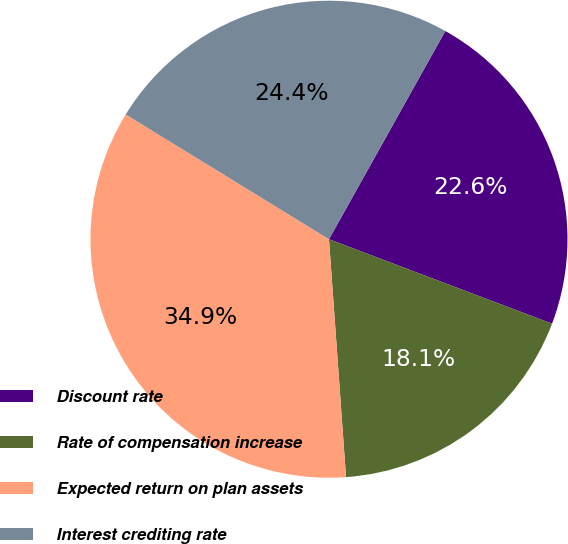Convert chart to OTSL. <chart><loc_0><loc_0><loc_500><loc_500><pie_chart><fcel>Discount rate<fcel>Rate of compensation increase<fcel>Expected return on plan assets<fcel>Interest crediting rate<nl><fcel>22.65%<fcel>18.1%<fcel>34.9%<fcel>24.35%<nl></chart> 